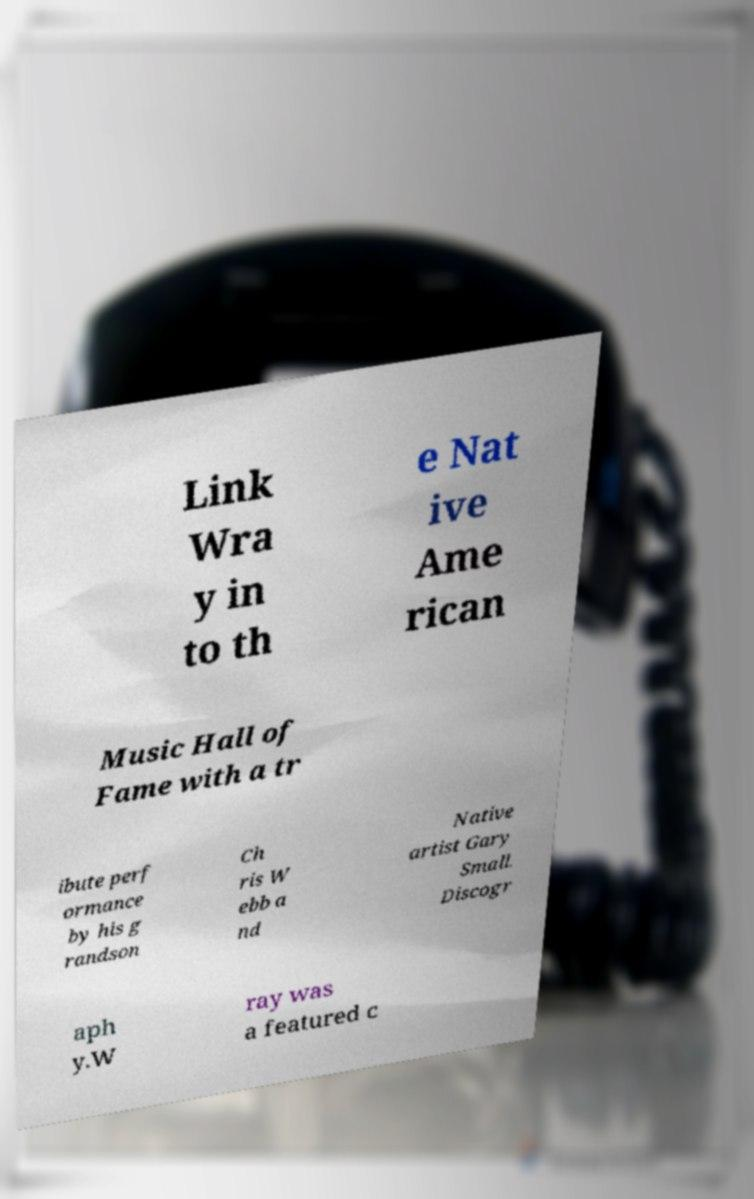Please identify and transcribe the text found in this image. Link Wra y in to th e Nat ive Ame rican Music Hall of Fame with a tr ibute perf ormance by his g randson Ch ris W ebb a nd Native artist Gary Small. Discogr aph y.W ray was a featured c 